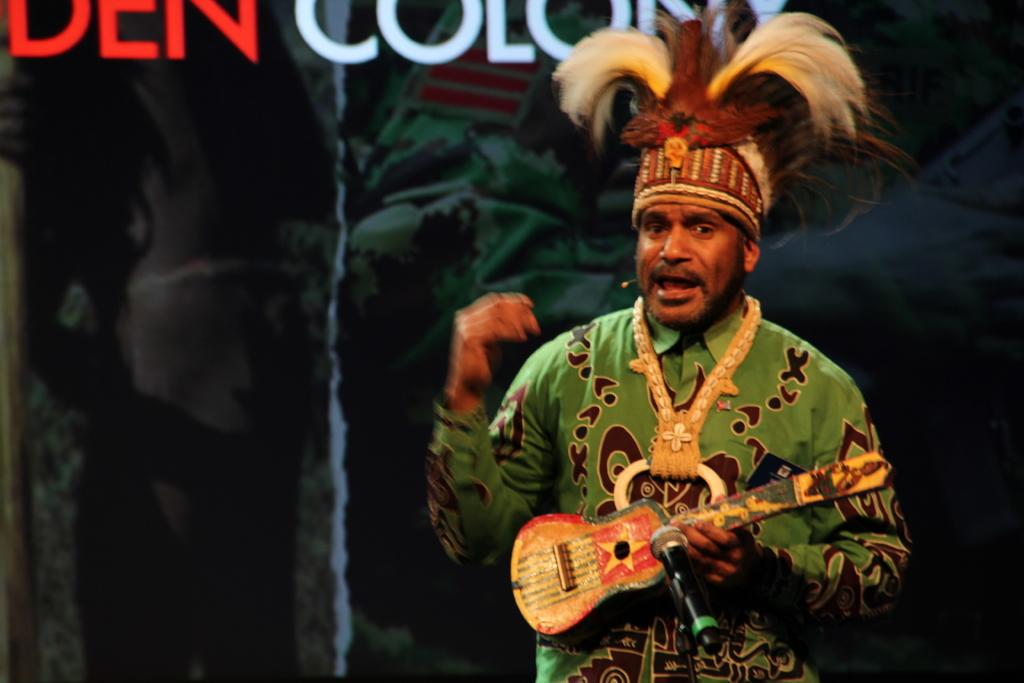What is the main subject of the image? There is a person standing in the image. What is the person wearing? The person is wearing a different costume. What object is the person holding? The person is holding a guitar. What is in front of the person? There is a microphone in front of the person. What type of impulse can be seen flowing through the person's flesh in the image? There is no indication of any impulse or flesh in the image; it features a person standing, wearing a costume, holding a guitar, and standing in front of a microphone. 